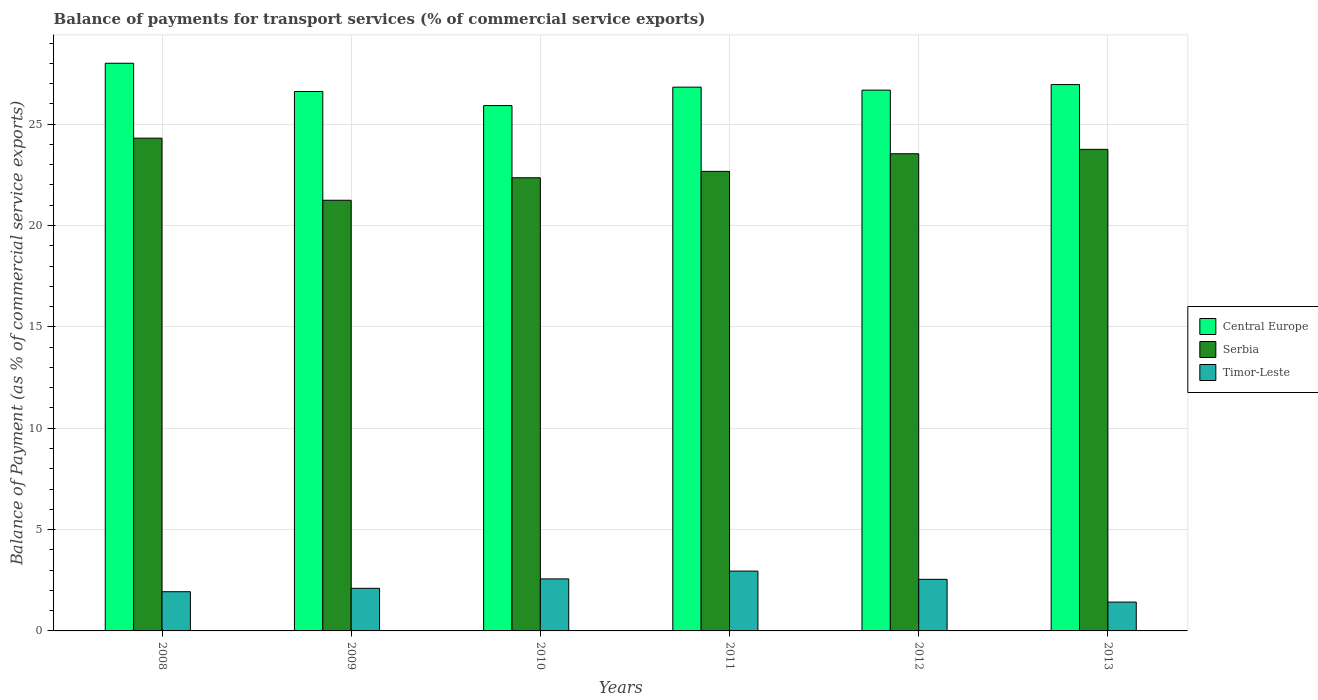How many different coloured bars are there?
Your response must be concise. 3. How many groups of bars are there?
Keep it short and to the point. 6. Are the number of bars on each tick of the X-axis equal?
Make the answer very short. Yes. How many bars are there on the 1st tick from the left?
Offer a very short reply. 3. What is the label of the 4th group of bars from the left?
Keep it short and to the point. 2011. What is the balance of payments for transport services in Serbia in 2008?
Keep it short and to the point. 24.31. Across all years, what is the maximum balance of payments for transport services in Serbia?
Offer a very short reply. 24.31. Across all years, what is the minimum balance of payments for transport services in Timor-Leste?
Keep it short and to the point. 1.42. In which year was the balance of payments for transport services in Serbia maximum?
Your answer should be very brief. 2008. In which year was the balance of payments for transport services in Timor-Leste minimum?
Make the answer very short. 2013. What is the total balance of payments for transport services in Serbia in the graph?
Your response must be concise. 137.86. What is the difference between the balance of payments for transport services in Central Europe in 2010 and that in 2013?
Give a very brief answer. -1.04. What is the difference between the balance of payments for transport services in Timor-Leste in 2008 and the balance of payments for transport services in Central Europe in 2013?
Offer a very short reply. -25.02. What is the average balance of payments for transport services in Central Europe per year?
Your answer should be compact. 26.83. In the year 2008, what is the difference between the balance of payments for transport services in Serbia and balance of payments for transport services in Timor-Leste?
Provide a short and direct response. 22.37. What is the ratio of the balance of payments for transport services in Central Europe in 2008 to that in 2011?
Give a very brief answer. 1.04. What is the difference between the highest and the second highest balance of payments for transport services in Timor-Leste?
Your answer should be very brief. 0.39. What is the difference between the highest and the lowest balance of payments for transport services in Serbia?
Your answer should be compact. 3.06. What does the 3rd bar from the left in 2011 represents?
Give a very brief answer. Timor-Leste. What does the 1st bar from the right in 2011 represents?
Ensure brevity in your answer.  Timor-Leste. Is it the case that in every year, the sum of the balance of payments for transport services in Timor-Leste and balance of payments for transport services in Serbia is greater than the balance of payments for transport services in Central Europe?
Your answer should be compact. No. Does the graph contain any zero values?
Offer a terse response. No. Does the graph contain grids?
Ensure brevity in your answer.  Yes. How many legend labels are there?
Offer a very short reply. 3. How are the legend labels stacked?
Give a very brief answer. Vertical. What is the title of the graph?
Make the answer very short. Balance of payments for transport services (% of commercial service exports). What is the label or title of the Y-axis?
Make the answer very short. Balance of Payment (as % of commercial service exports). What is the Balance of Payment (as % of commercial service exports) of Central Europe in 2008?
Keep it short and to the point. 28. What is the Balance of Payment (as % of commercial service exports) in Serbia in 2008?
Provide a short and direct response. 24.31. What is the Balance of Payment (as % of commercial service exports) of Timor-Leste in 2008?
Ensure brevity in your answer.  1.93. What is the Balance of Payment (as % of commercial service exports) of Central Europe in 2009?
Your response must be concise. 26.61. What is the Balance of Payment (as % of commercial service exports) in Serbia in 2009?
Keep it short and to the point. 21.24. What is the Balance of Payment (as % of commercial service exports) of Timor-Leste in 2009?
Your answer should be compact. 2.1. What is the Balance of Payment (as % of commercial service exports) in Central Europe in 2010?
Provide a succinct answer. 25.91. What is the Balance of Payment (as % of commercial service exports) in Serbia in 2010?
Offer a very short reply. 22.35. What is the Balance of Payment (as % of commercial service exports) of Timor-Leste in 2010?
Offer a terse response. 2.57. What is the Balance of Payment (as % of commercial service exports) of Central Europe in 2011?
Your response must be concise. 26.82. What is the Balance of Payment (as % of commercial service exports) of Serbia in 2011?
Your answer should be very brief. 22.67. What is the Balance of Payment (as % of commercial service exports) of Timor-Leste in 2011?
Your answer should be very brief. 2.95. What is the Balance of Payment (as % of commercial service exports) of Central Europe in 2012?
Your answer should be compact. 26.68. What is the Balance of Payment (as % of commercial service exports) of Serbia in 2012?
Ensure brevity in your answer.  23.54. What is the Balance of Payment (as % of commercial service exports) of Timor-Leste in 2012?
Make the answer very short. 2.55. What is the Balance of Payment (as % of commercial service exports) in Central Europe in 2013?
Provide a succinct answer. 26.95. What is the Balance of Payment (as % of commercial service exports) of Serbia in 2013?
Make the answer very short. 23.75. What is the Balance of Payment (as % of commercial service exports) in Timor-Leste in 2013?
Provide a succinct answer. 1.42. Across all years, what is the maximum Balance of Payment (as % of commercial service exports) of Central Europe?
Offer a terse response. 28. Across all years, what is the maximum Balance of Payment (as % of commercial service exports) of Serbia?
Your response must be concise. 24.31. Across all years, what is the maximum Balance of Payment (as % of commercial service exports) in Timor-Leste?
Offer a very short reply. 2.95. Across all years, what is the minimum Balance of Payment (as % of commercial service exports) of Central Europe?
Your response must be concise. 25.91. Across all years, what is the minimum Balance of Payment (as % of commercial service exports) in Serbia?
Your response must be concise. 21.24. Across all years, what is the minimum Balance of Payment (as % of commercial service exports) of Timor-Leste?
Provide a succinct answer. 1.42. What is the total Balance of Payment (as % of commercial service exports) in Central Europe in the graph?
Provide a short and direct response. 160.97. What is the total Balance of Payment (as % of commercial service exports) of Serbia in the graph?
Give a very brief answer. 137.86. What is the total Balance of Payment (as % of commercial service exports) of Timor-Leste in the graph?
Your answer should be very brief. 13.52. What is the difference between the Balance of Payment (as % of commercial service exports) in Central Europe in 2008 and that in 2009?
Give a very brief answer. 1.39. What is the difference between the Balance of Payment (as % of commercial service exports) of Serbia in 2008 and that in 2009?
Your answer should be compact. 3.06. What is the difference between the Balance of Payment (as % of commercial service exports) in Timor-Leste in 2008 and that in 2009?
Make the answer very short. -0.17. What is the difference between the Balance of Payment (as % of commercial service exports) in Central Europe in 2008 and that in 2010?
Offer a very short reply. 2.09. What is the difference between the Balance of Payment (as % of commercial service exports) of Serbia in 2008 and that in 2010?
Offer a terse response. 1.95. What is the difference between the Balance of Payment (as % of commercial service exports) of Timor-Leste in 2008 and that in 2010?
Keep it short and to the point. -0.63. What is the difference between the Balance of Payment (as % of commercial service exports) of Central Europe in 2008 and that in 2011?
Make the answer very short. 1.18. What is the difference between the Balance of Payment (as % of commercial service exports) of Serbia in 2008 and that in 2011?
Provide a short and direct response. 1.64. What is the difference between the Balance of Payment (as % of commercial service exports) of Timor-Leste in 2008 and that in 2011?
Keep it short and to the point. -1.02. What is the difference between the Balance of Payment (as % of commercial service exports) in Central Europe in 2008 and that in 2012?
Ensure brevity in your answer.  1.33. What is the difference between the Balance of Payment (as % of commercial service exports) in Serbia in 2008 and that in 2012?
Offer a very short reply. 0.77. What is the difference between the Balance of Payment (as % of commercial service exports) in Timor-Leste in 2008 and that in 2012?
Offer a terse response. -0.61. What is the difference between the Balance of Payment (as % of commercial service exports) in Central Europe in 2008 and that in 2013?
Keep it short and to the point. 1.05. What is the difference between the Balance of Payment (as % of commercial service exports) in Serbia in 2008 and that in 2013?
Offer a terse response. 0.55. What is the difference between the Balance of Payment (as % of commercial service exports) in Timor-Leste in 2008 and that in 2013?
Ensure brevity in your answer.  0.51. What is the difference between the Balance of Payment (as % of commercial service exports) of Central Europe in 2009 and that in 2010?
Offer a terse response. 0.69. What is the difference between the Balance of Payment (as % of commercial service exports) of Serbia in 2009 and that in 2010?
Provide a succinct answer. -1.11. What is the difference between the Balance of Payment (as % of commercial service exports) in Timor-Leste in 2009 and that in 2010?
Provide a short and direct response. -0.46. What is the difference between the Balance of Payment (as % of commercial service exports) in Central Europe in 2009 and that in 2011?
Your answer should be very brief. -0.22. What is the difference between the Balance of Payment (as % of commercial service exports) of Serbia in 2009 and that in 2011?
Make the answer very short. -1.43. What is the difference between the Balance of Payment (as % of commercial service exports) in Timor-Leste in 2009 and that in 2011?
Your answer should be very brief. -0.85. What is the difference between the Balance of Payment (as % of commercial service exports) of Central Europe in 2009 and that in 2012?
Provide a succinct answer. -0.07. What is the difference between the Balance of Payment (as % of commercial service exports) in Serbia in 2009 and that in 2012?
Provide a short and direct response. -2.29. What is the difference between the Balance of Payment (as % of commercial service exports) of Timor-Leste in 2009 and that in 2012?
Ensure brevity in your answer.  -0.44. What is the difference between the Balance of Payment (as % of commercial service exports) in Central Europe in 2009 and that in 2013?
Offer a terse response. -0.34. What is the difference between the Balance of Payment (as % of commercial service exports) in Serbia in 2009 and that in 2013?
Give a very brief answer. -2.51. What is the difference between the Balance of Payment (as % of commercial service exports) in Timor-Leste in 2009 and that in 2013?
Offer a very short reply. 0.68. What is the difference between the Balance of Payment (as % of commercial service exports) of Central Europe in 2010 and that in 2011?
Keep it short and to the point. -0.91. What is the difference between the Balance of Payment (as % of commercial service exports) of Serbia in 2010 and that in 2011?
Give a very brief answer. -0.32. What is the difference between the Balance of Payment (as % of commercial service exports) of Timor-Leste in 2010 and that in 2011?
Your answer should be compact. -0.39. What is the difference between the Balance of Payment (as % of commercial service exports) in Central Europe in 2010 and that in 2012?
Provide a short and direct response. -0.76. What is the difference between the Balance of Payment (as % of commercial service exports) in Serbia in 2010 and that in 2012?
Provide a short and direct response. -1.18. What is the difference between the Balance of Payment (as % of commercial service exports) of Timor-Leste in 2010 and that in 2012?
Offer a very short reply. 0.02. What is the difference between the Balance of Payment (as % of commercial service exports) in Central Europe in 2010 and that in 2013?
Provide a succinct answer. -1.04. What is the difference between the Balance of Payment (as % of commercial service exports) in Serbia in 2010 and that in 2013?
Keep it short and to the point. -1.4. What is the difference between the Balance of Payment (as % of commercial service exports) of Timor-Leste in 2010 and that in 2013?
Your response must be concise. 1.14. What is the difference between the Balance of Payment (as % of commercial service exports) in Central Europe in 2011 and that in 2012?
Offer a very short reply. 0.15. What is the difference between the Balance of Payment (as % of commercial service exports) of Serbia in 2011 and that in 2012?
Provide a succinct answer. -0.87. What is the difference between the Balance of Payment (as % of commercial service exports) in Timor-Leste in 2011 and that in 2012?
Provide a short and direct response. 0.41. What is the difference between the Balance of Payment (as % of commercial service exports) of Central Europe in 2011 and that in 2013?
Your response must be concise. -0.13. What is the difference between the Balance of Payment (as % of commercial service exports) of Serbia in 2011 and that in 2013?
Your answer should be compact. -1.09. What is the difference between the Balance of Payment (as % of commercial service exports) of Timor-Leste in 2011 and that in 2013?
Offer a terse response. 1.53. What is the difference between the Balance of Payment (as % of commercial service exports) in Central Europe in 2012 and that in 2013?
Offer a terse response. -0.27. What is the difference between the Balance of Payment (as % of commercial service exports) in Serbia in 2012 and that in 2013?
Ensure brevity in your answer.  -0.22. What is the difference between the Balance of Payment (as % of commercial service exports) in Timor-Leste in 2012 and that in 2013?
Make the answer very short. 1.12. What is the difference between the Balance of Payment (as % of commercial service exports) in Central Europe in 2008 and the Balance of Payment (as % of commercial service exports) in Serbia in 2009?
Provide a succinct answer. 6.76. What is the difference between the Balance of Payment (as % of commercial service exports) of Central Europe in 2008 and the Balance of Payment (as % of commercial service exports) of Timor-Leste in 2009?
Your answer should be compact. 25.9. What is the difference between the Balance of Payment (as % of commercial service exports) of Serbia in 2008 and the Balance of Payment (as % of commercial service exports) of Timor-Leste in 2009?
Your answer should be compact. 22.21. What is the difference between the Balance of Payment (as % of commercial service exports) in Central Europe in 2008 and the Balance of Payment (as % of commercial service exports) in Serbia in 2010?
Offer a terse response. 5.65. What is the difference between the Balance of Payment (as % of commercial service exports) in Central Europe in 2008 and the Balance of Payment (as % of commercial service exports) in Timor-Leste in 2010?
Ensure brevity in your answer.  25.44. What is the difference between the Balance of Payment (as % of commercial service exports) of Serbia in 2008 and the Balance of Payment (as % of commercial service exports) of Timor-Leste in 2010?
Keep it short and to the point. 21.74. What is the difference between the Balance of Payment (as % of commercial service exports) of Central Europe in 2008 and the Balance of Payment (as % of commercial service exports) of Serbia in 2011?
Give a very brief answer. 5.33. What is the difference between the Balance of Payment (as % of commercial service exports) of Central Europe in 2008 and the Balance of Payment (as % of commercial service exports) of Timor-Leste in 2011?
Provide a short and direct response. 25.05. What is the difference between the Balance of Payment (as % of commercial service exports) of Serbia in 2008 and the Balance of Payment (as % of commercial service exports) of Timor-Leste in 2011?
Offer a very short reply. 21.36. What is the difference between the Balance of Payment (as % of commercial service exports) in Central Europe in 2008 and the Balance of Payment (as % of commercial service exports) in Serbia in 2012?
Your response must be concise. 4.46. What is the difference between the Balance of Payment (as % of commercial service exports) in Central Europe in 2008 and the Balance of Payment (as % of commercial service exports) in Timor-Leste in 2012?
Offer a very short reply. 25.46. What is the difference between the Balance of Payment (as % of commercial service exports) in Serbia in 2008 and the Balance of Payment (as % of commercial service exports) in Timor-Leste in 2012?
Offer a very short reply. 21.76. What is the difference between the Balance of Payment (as % of commercial service exports) of Central Europe in 2008 and the Balance of Payment (as % of commercial service exports) of Serbia in 2013?
Keep it short and to the point. 4.25. What is the difference between the Balance of Payment (as % of commercial service exports) of Central Europe in 2008 and the Balance of Payment (as % of commercial service exports) of Timor-Leste in 2013?
Offer a very short reply. 26.58. What is the difference between the Balance of Payment (as % of commercial service exports) in Serbia in 2008 and the Balance of Payment (as % of commercial service exports) in Timor-Leste in 2013?
Your answer should be very brief. 22.88. What is the difference between the Balance of Payment (as % of commercial service exports) of Central Europe in 2009 and the Balance of Payment (as % of commercial service exports) of Serbia in 2010?
Your answer should be very brief. 4.25. What is the difference between the Balance of Payment (as % of commercial service exports) in Central Europe in 2009 and the Balance of Payment (as % of commercial service exports) in Timor-Leste in 2010?
Make the answer very short. 24.04. What is the difference between the Balance of Payment (as % of commercial service exports) in Serbia in 2009 and the Balance of Payment (as % of commercial service exports) in Timor-Leste in 2010?
Offer a terse response. 18.68. What is the difference between the Balance of Payment (as % of commercial service exports) of Central Europe in 2009 and the Balance of Payment (as % of commercial service exports) of Serbia in 2011?
Provide a succinct answer. 3.94. What is the difference between the Balance of Payment (as % of commercial service exports) of Central Europe in 2009 and the Balance of Payment (as % of commercial service exports) of Timor-Leste in 2011?
Offer a terse response. 23.66. What is the difference between the Balance of Payment (as % of commercial service exports) of Serbia in 2009 and the Balance of Payment (as % of commercial service exports) of Timor-Leste in 2011?
Provide a succinct answer. 18.29. What is the difference between the Balance of Payment (as % of commercial service exports) of Central Europe in 2009 and the Balance of Payment (as % of commercial service exports) of Serbia in 2012?
Offer a terse response. 3.07. What is the difference between the Balance of Payment (as % of commercial service exports) in Central Europe in 2009 and the Balance of Payment (as % of commercial service exports) in Timor-Leste in 2012?
Make the answer very short. 24.06. What is the difference between the Balance of Payment (as % of commercial service exports) in Serbia in 2009 and the Balance of Payment (as % of commercial service exports) in Timor-Leste in 2012?
Keep it short and to the point. 18.7. What is the difference between the Balance of Payment (as % of commercial service exports) of Central Europe in 2009 and the Balance of Payment (as % of commercial service exports) of Serbia in 2013?
Offer a terse response. 2.85. What is the difference between the Balance of Payment (as % of commercial service exports) of Central Europe in 2009 and the Balance of Payment (as % of commercial service exports) of Timor-Leste in 2013?
Your response must be concise. 25.18. What is the difference between the Balance of Payment (as % of commercial service exports) in Serbia in 2009 and the Balance of Payment (as % of commercial service exports) in Timor-Leste in 2013?
Your answer should be very brief. 19.82. What is the difference between the Balance of Payment (as % of commercial service exports) in Central Europe in 2010 and the Balance of Payment (as % of commercial service exports) in Serbia in 2011?
Your answer should be very brief. 3.25. What is the difference between the Balance of Payment (as % of commercial service exports) of Central Europe in 2010 and the Balance of Payment (as % of commercial service exports) of Timor-Leste in 2011?
Make the answer very short. 22.96. What is the difference between the Balance of Payment (as % of commercial service exports) of Serbia in 2010 and the Balance of Payment (as % of commercial service exports) of Timor-Leste in 2011?
Provide a short and direct response. 19.4. What is the difference between the Balance of Payment (as % of commercial service exports) of Central Europe in 2010 and the Balance of Payment (as % of commercial service exports) of Serbia in 2012?
Your answer should be very brief. 2.38. What is the difference between the Balance of Payment (as % of commercial service exports) of Central Europe in 2010 and the Balance of Payment (as % of commercial service exports) of Timor-Leste in 2012?
Your answer should be very brief. 23.37. What is the difference between the Balance of Payment (as % of commercial service exports) in Serbia in 2010 and the Balance of Payment (as % of commercial service exports) in Timor-Leste in 2012?
Provide a succinct answer. 19.81. What is the difference between the Balance of Payment (as % of commercial service exports) of Central Europe in 2010 and the Balance of Payment (as % of commercial service exports) of Serbia in 2013?
Your answer should be compact. 2.16. What is the difference between the Balance of Payment (as % of commercial service exports) of Central Europe in 2010 and the Balance of Payment (as % of commercial service exports) of Timor-Leste in 2013?
Ensure brevity in your answer.  24.49. What is the difference between the Balance of Payment (as % of commercial service exports) in Serbia in 2010 and the Balance of Payment (as % of commercial service exports) in Timor-Leste in 2013?
Keep it short and to the point. 20.93. What is the difference between the Balance of Payment (as % of commercial service exports) of Central Europe in 2011 and the Balance of Payment (as % of commercial service exports) of Serbia in 2012?
Offer a terse response. 3.29. What is the difference between the Balance of Payment (as % of commercial service exports) of Central Europe in 2011 and the Balance of Payment (as % of commercial service exports) of Timor-Leste in 2012?
Your response must be concise. 24.28. What is the difference between the Balance of Payment (as % of commercial service exports) in Serbia in 2011 and the Balance of Payment (as % of commercial service exports) in Timor-Leste in 2012?
Your answer should be very brief. 20.12. What is the difference between the Balance of Payment (as % of commercial service exports) of Central Europe in 2011 and the Balance of Payment (as % of commercial service exports) of Serbia in 2013?
Offer a very short reply. 3.07. What is the difference between the Balance of Payment (as % of commercial service exports) of Central Europe in 2011 and the Balance of Payment (as % of commercial service exports) of Timor-Leste in 2013?
Offer a very short reply. 25.4. What is the difference between the Balance of Payment (as % of commercial service exports) of Serbia in 2011 and the Balance of Payment (as % of commercial service exports) of Timor-Leste in 2013?
Keep it short and to the point. 21.25. What is the difference between the Balance of Payment (as % of commercial service exports) in Central Europe in 2012 and the Balance of Payment (as % of commercial service exports) in Serbia in 2013?
Your answer should be very brief. 2.92. What is the difference between the Balance of Payment (as % of commercial service exports) of Central Europe in 2012 and the Balance of Payment (as % of commercial service exports) of Timor-Leste in 2013?
Provide a short and direct response. 25.25. What is the difference between the Balance of Payment (as % of commercial service exports) of Serbia in 2012 and the Balance of Payment (as % of commercial service exports) of Timor-Leste in 2013?
Offer a terse response. 22.11. What is the average Balance of Payment (as % of commercial service exports) of Central Europe per year?
Provide a short and direct response. 26.83. What is the average Balance of Payment (as % of commercial service exports) in Serbia per year?
Keep it short and to the point. 22.98. What is the average Balance of Payment (as % of commercial service exports) in Timor-Leste per year?
Your response must be concise. 2.25. In the year 2008, what is the difference between the Balance of Payment (as % of commercial service exports) of Central Europe and Balance of Payment (as % of commercial service exports) of Serbia?
Give a very brief answer. 3.69. In the year 2008, what is the difference between the Balance of Payment (as % of commercial service exports) in Central Europe and Balance of Payment (as % of commercial service exports) in Timor-Leste?
Offer a terse response. 26.07. In the year 2008, what is the difference between the Balance of Payment (as % of commercial service exports) in Serbia and Balance of Payment (as % of commercial service exports) in Timor-Leste?
Give a very brief answer. 22.37. In the year 2009, what is the difference between the Balance of Payment (as % of commercial service exports) in Central Europe and Balance of Payment (as % of commercial service exports) in Serbia?
Ensure brevity in your answer.  5.36. In the year 2009, what is the difference between the Balance of Payment (as % of commercial service exports) in Central Europe and Balance of Payment (as % of commercial service exports) in Timor-Leste?
Provide a short and direct response. 24.51. In the year 2009, what is the difference between the Balance of Payment (as % of commercial service exports) in Serbia and Balance of Payment (as % of commercial service exports) in Timor-Leste?
Your response must be concise. 19.14. In the year 2010, what is the difference between the Balance of Payment (as % of commercial service exports) in Central Europe and Balance of Payment (as % of commercial service exports) in Serbia?
Offer a terse response. 3.56. In the year 2010, what is the difference between the Balance of Payment (as % of commercial service exports) in Central Europe and Balance of Payment (as % of commercial service exports) in Timor-Leste?
Provide a short and direct response. 23.35. In the year 2010, what is the difference between the Balance of Payment (as % of commercial service exports) of Serbia and Balance of Payment (as % of commercial service exports) of Timor-Leste?
Ensure brevity in your answer.  19.79. In the year 2011, what is the difference between the Balance of Payment (as % of commercial service exports) of Central Europe and Balance of Payment (as % of commercial service exports) of Serbia?
Provide a short and direct response. 4.15. In the year 2011, what is the difference between the Balance of Payment (as % of commercial service exports) of Central Europe and Balance of Payment (as % of commercial service exports) of Timor-Leste?
Your response must be concise. 23.87. In the year 2011, what is the difference between the Balance of Payment (as % of commercial service exports) in Serbia and Balance of Payment (as % of commercial service exports) in Timor-Leste?
Make the answer very short. 19.72. In the year 2012, what is the difference between the Balance of Payment (as % of commercial service exports) of Central Europe and Balance of Payment (as % of commercial service exports) of Serbia?
Offer a terse response. 3.14. In the year 2012, what is the difference between the Balance of Payment (as % of commercial service exports) of Central Europe and Balance of Payment (as % of commercial service exports) of Timor-Leste?
Make the answer very short. 24.13. In the year 2012, what is the difference between the Balance of Payment (as % of commercial service exports) of Serbia and Balance of Payment (as % of commercial service exports) of Timor-Leste?
Offer a terse response. 20.99. In the year 2013, what is the difference between the Balance of Payment (as % of commercial service exports) in Central Europe and Balance of Payment (as % of commercial service exports) in Serbia?
Make the answer very short. 3.2. In the year 2013, what is the difference between the Balance of Payment (as % of commercial service exports) in Central Europe and Balance of Payment (as % of commercial service exports) in Timor-Leste?
Your answer should be compact. 25.53. In the year 2013, what is the difference between the Balance of Payment (as % of commercial service exports) in Serbia and Balance of Payment (as % of commercial service exports) in Timor-Leste?
Your answer should be very brief. 22.33. What is the ratio of the Balance of Payment (as % of commercial service exports) in Central Europe in 2008 to that in 2009?
Provide a short and direct response. 1.05. What is the ratio of the Balance of Payment (as % of commercial service exports) in Serbia in 2008 to that in 2009?
Ensure brevity in your answer.  1.14. What is the ratio of the Balance of Payment (as % of commercial service exports) in Timor-Leste in 2008 to that in 2009?
Keep it short and to the point. 0.92. What is the ratio of the Balance of Payment (as % of commercial service exports) of Central Europe in 2008 to that in 2010?
Make the answer very short. 1.08. What is the ratio of the Balance of Payment (as % of commercial service exports) of Serbia in 2008 to that in 2010?
Ensure brevity in your answer.  1.09. What is the ratio of the Balance of Payment (as % of commercial service exports) of Timor-Leste in 2008 to that in 2010?
Make the answer very short. 0.75. What is the ratio of the Balance of Payment (as % of commercial service exports) of Central Europe in 2008 to that in 2011?
Your answer should be very brief. 1.04. What is the ratio of the Balance of Payment (as % of commercial service exports) in Serbia in 2008 to that in 2011?
Give a very brief answer. 1.07. What is the ratio of the Balance of Payment (as % of commercial service exports) of Timor-Leste in 2008 to that in 2011?
Provide a short and direct response. 0.66. What is the ratio of the Balance of Payment (as % of commercial service exports) in Central Europe in 2008 to that in 2012?
Keep it short and to the point. 1.05. What is the ratio of the Balance of Payment (as % of commercial service exports) in Serbia in 2008 to that in 2012?
Provide a succinct answer. 1.03. What is the ratio of the Balance of Payment (as % of commercial service exports) in Timor-Leste in 2008 to that in 2012?
Your answer should be compact. 0.76. What is the ratio of the Balance of Payment (as % of commercial service exports) in Central Europe in 2008 to that in 2013?
Make the answer very short. 1.04. What is the ratio of the Balance of Payment (as % of commercial service exports) of Serbia in 2008 to that in 2013?
Offer a terse response. 1.02. What is the ratio of the Balance of Payment (as % of commercial service exports) in Timor-Leste in 2008 to that in 2013?
Your response must be concise. 1.36. What is the ratio of the Balance of Payment (as % of commercial service exports) of Central Europe in 2009 to that in 2010?
Give a very brief answer. 1.03. What is the ratio of the Balance of Payment (as % of commercial service exports) of Serbia in 2009 to that in 2010?
Provide a succinct answer. 0.95. What is the ratio of the Balance of Payment (as % of commercial service exports) of Timor-Leste in 2009 to that in 2010?
Offer a terse response. 0.82. What is the ratio of the Balance of Payment (as % of commercial service exports) of Serbia in 2009 to that in 2011?
Make the answer very short. 0.94. What is the ratio of the Balance of Payment (as % of commercial service exports) in Timor-Leste in 2009 to that in 2011?
Offer a very short reply. 0.71. What is the ratio of the Balance of Payment (as % of commercial service exports) of Central Europe in 2009 to that in 2012?
Give a very brief answer. 1. What is the ratio of the Balance of Payment (as % of commercial service exports) in Serbia in 2009 to that in 2012?
Give a very brief answer. 0.9. What is the ratio of the Balance of Payment (as % of commercial service exports) in Timor-Leste in 2009 to that in 2012?
Your answer should be very brief. 0.83. What is the ratio of the Balance of Payment (as % of commercial service exports) in Central Europe in 2009 to that in 2013?
Provide a short and direct response. 0.99. What is the ratio of the Balance of Payment (as % of commercial service exports) in Serbia in 2009 to that in 2013?
Give a very brief answer. 0.89. What is the ratio of the Balance of Payment (as % of commercial service exports) in Timor-Leste in 2009 to that in 2013?
Ensure brevity in your answer.  1.48. What is the ratio of the Balance of Payment (as % of commercial service exports) of Central Europe in 2010 to that in 2011?
Your answer should be very brief. 0.97. What is the ratio of the Balance of Payment (as % of commercial service exports) of Serbia in 2010 to that in 2011?
Your answer should be compact. 0.99. What is the ratio of the Balance of Payment (as % of commercial service exports) in Timor-Leste in 2010 to that in 2011?
Your answer should be very brief. 0.87. What is the ratio of the Balance of Payment (as % of commercial service exports) of Central Europe in 2010 to that in 2012?
Offer a very short reply. 0.97. What is the ratio of the Balance of Payment (as % of commercial service exports) of Serbia in 2010 to that in 2012?
Give a very brief answer. 0.95. What is the ratio of the Balance of Payment (as % of commercial service exports) in Central Europe in 2010 to that in 2013?
Your response must be concise. 0.96. What is the ratio of the Balance of Payment (as % of commercial service exports) of Serbia in 2010 to that in 2013?
Offer a very short reply. 0.94. What is the ratio of the Balance of Payment (as % of commercial service exports) of Timor-Leste in 2010 to that in 2013?
Your answer should be compact. 1.8. What is the ratio of the Balance of Payment (as % of commercial service exports) of Serbia in 2011 to that in 2012?
Keep it short and to the point. 0.96. What is the ratio of the Balance of Payment (as % of commercial service exports) of Timor-Leste in 2011 to that in 2012?
Offer a terse response. 1.16. What is the ratio of the Balance of Payment (as % of commercial service exports) of Serbia in 2011 to that in 2013?
Offer a very short reply. 0.95. What is the ratio of the Balance of Payment (as % of commercial service exports) of Timor-Leste in 2011 to that in 2013?
Make the answer very short. 2.07. What is the ratio of the Balance of Payment (as % of commercial service exports) of Central Europe in 2012 to that in 2013?
Provide a short and direct response. 0.99. What is the ratio of the Balance of Payment (as % of commercial service exports) of Serbia in 2012 to that in 2013?
Provide a short and direct response. 0.99. What is the ratio of the Balance of Payment (as % of commercial service exports) in Timor-Leste in 2012 to that in 2013?
Your answer should be very brief. 1.79. What is the difference between the highest and the second highest Balance of Payment (as % of commercial service exports) in Central Europe?
Offer a terse response. 1.05. What is the difference between the highest and the second highest Balance of Payment (as % of commercial service exports) of Serbia?
Offer a very short reply. 0.55. What is the difference between the highest and the second highest Balance of Payment (as % of commercial service exports) of Timor-Leste?
Give a very brief answer. 0.39. What is the difference between the highest and the lowest Balance of Payment (as % of commercial service exports) in Central Europe?
Provide a short and direct response. 2.09. What is the difference between the highest and the lowest Balance of Payment (as % of commercial service exports) in Serbia?
Your answer should be very brief. 3.06. What is the difference between the highest and the lowest Balance of Payment (as % of commercial service exports) of Timor-Leste?
Offer a very short reply. 1.53. 